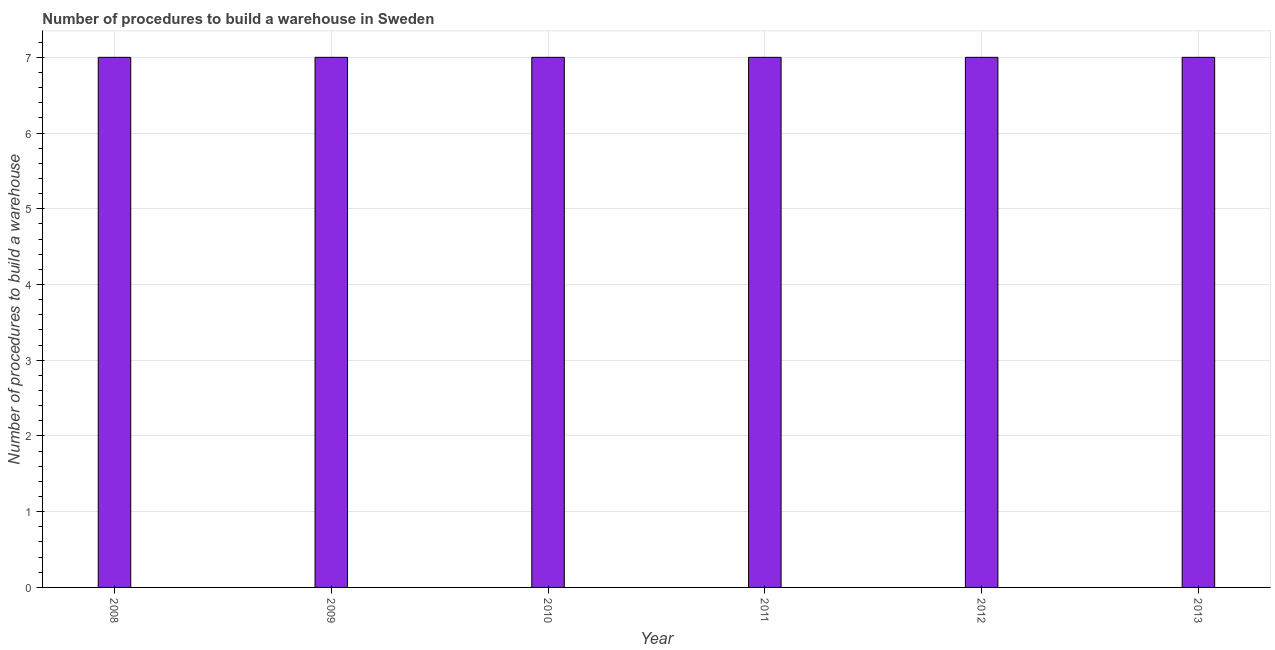What is the title of the graph?
Your answer should be compact. Number of procedures to build a warehouse in Sweden. What is the label or title of the X-axis?
Provide a short and direct response. Year. What is the label or title of the Y-axis?
Ensure brevity in your answer.  Number of procedures to build a warehouse. Across all years, what is the minimum number of procedures to build a warehouse?
Ensure brevity in your answer.  7. In which year was the number of procedures to build a warehouse maximum?
Your response must be concise. 2008. What is the sum of the number of procedures to build a warehouse?
Provide a succinct answer. 42. What is the average number of procedures to build a warehouse per year?
Your answer should be compact. 7. What is the ratio of the number of procedures to build a warehouse in 2010 to that in 2012?
Your answer should be compact. 1. Is the number of procedures to build a warehouse in 2011 less than that in 2012?
Keep it short and to the point. No. Is the difference between the number of procedures to build a warehouse in 2009 and 2012 greater than the difference between any two years?
Provide a short and direct response. Yes. Is the sum of the number of procedures to build a warehouse in 2011 and 2013 greater than the maximum number of procedures to build a warehouse across all years?
Offer a very short reply. Yes. In how many years, is the number of procedures to build a warehouse greater than the average number of procedures to build a warehouse taken over all years?
Make the answer very short. 0. What is the Number of procedures to build a warehouse of 2008?
Offer a very short reply. 7. What is the Number of procedures to build a warehouse in 2011?
Make the answer very short. 7. What is the Number of procedures to build a warehouse in 2013?
Your answer should be very brief. 7. What is the difference between the Number of procedures to build a warehouse in 2008 and 2011?
Keep it short and to the point. 0. What is the difference between the Number of procedures to build a warehouse in 2008 and 2012?
Keep it short and to the point. 0. What is the difference between the Number of procedures to build a warehouse in 2008 and 2013?
Offer a terse response. 0. What is the difference between the Number of procedures to build a warehouse in 2009 and 2010?
Make the answer very short. 0. What is the difference between the Number of procedures to build a warehouse in 2010 and 2012?
Keep it short and to the point. 0. What is the difference between the Number of procedures to build a warehouse in 2010 and 2013?
Make the answer very short. 0. What is the difference between the Number of procedures to build a warehouse in 2011 and 2013?
Provide a succinct answer. 0. What is the difference between the Number of procedures to build a warehouse in 2012 and 2013?
Make the answer very short. 0. What is the ratio of the Number of procedures to build a warehouse in 2008 to that in 2009?
Provide a succinct answer. 1. What is the ratio of the Number of procedures to build a warehouse in 2008 to that in 2010?
Ensure brevity in your answer.  1. What is the ratio of the Number of procedures to build a warehouse in 2008 to that in 2012?
Keep it short and to the point. 1. What is the ratio of the Number of procedures to build a warehouse in 2009 to that in 2011?
Your answer should be compact. 1. What is the ratio of the Number of procedures to build a warehouse in 2009 to that in 2012?
Your response must be concise. 1. What is the ratio of the Number of procedures to build a warehouse in 2009 to that in 2013?
Provide a succinct answer. 1. What is the ratio of the Number of procedures to build a warehouse in 2010 to that in 2012?
Offer a terse response. 1. What is the ratio of the Number of procedures to build a warehouse in 2010 to that in 2013?
Make the answer very short. 1. What is the ratio of the Number of procedures to build a warehouse in 2011 to that in 2012?
Ensure brevity in your answer.  1. What is the ratio of the Number of procedures to build a warehouse in 2012 to that in 2013?
Provide a short and direct response. 1. 